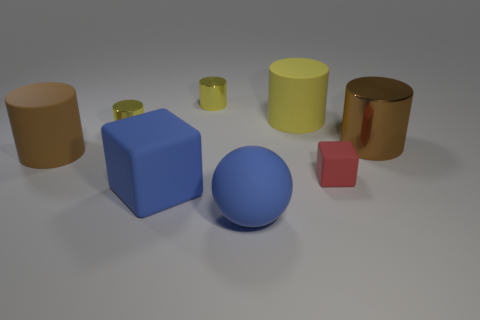Subtract all yellow cylinders. How many were subtracted if there are1yellow cylinders left? 2 Subtract all big yellow matte cylinders. How many cylinders are left? 4 Subtract all cyan balls. How many yellow cylinders are left? 3 Add 1 large shiny spheres. How many objects exist? 9 Subtract all yellow cylinders. How many cylinders are left? 2 Subtract 2 cylinders. How many cylinders are left? 3 Subtract all spheres. How many objects are left? 7 Add 2 small brown metallic cylinders. How many small brown metallic cylinders exist? 2 Subtract 0 gray cylinders. How many objects are left? 8 Subtract all cyan cubes. Subtract all red spheres. How many cubes are left? 2 